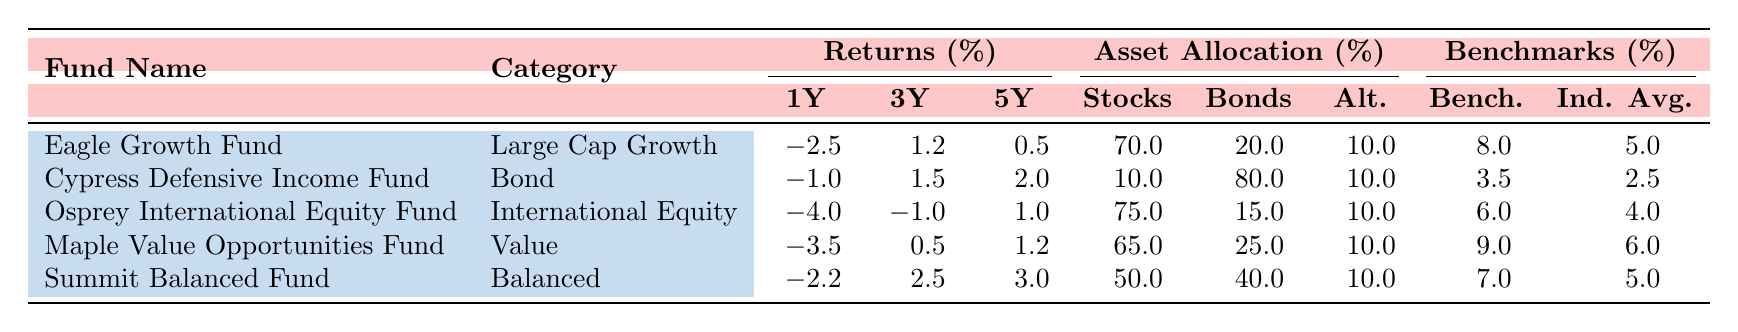What is the one-year return of the Eagle Growth Fund? The one-year return is listed in the table under the "Returns (%)” section for the Eagle Growth Fund, which is -2.5%.
Answer: -2.5% Which fund has the highest five-year return? The highest five-year return can be determined by comparing the values in the "5Y" column. The Summit Balanced Fund has the highest value at 3.0%.
Answer: Summit Balanced Fund What is the asset allocation for bonds in the Cypress Defensive Income Fund? The asset allocation for bonds in the Cypress Defensive Income Fund is specified in the "Asset Allocation (%)" section, which shows 80.0% for bonds.
Answer: 80.0% How does the one-year return of the Osprey International Equity Fund compare to its benchmark return? The one-year return of the Osprey International Equity Fund is -4.0%, while its benchmark return is 6.0%. The difference indicates that the fund is underperforming its benchmark by 10.0%.
Answer: Underperforming by 10.0% What is the total asset allocation percentage for stocks and bonds in the Maple Value Opportunities Fund? To find the total allocation, sum the stocks (65.0%) and bonds (25.0%) allocations listed for the Maple Value Opportunities Fund: 65.0% + 25.0% = 90.0%.
Answer: 90.0% Is the three-year return of the Summit Balanced Fund above the industry average return? The three-year return for the Summit Balanced Fund is 2.5%, while the industry average return is 5.0%. Since 2.5% is below 5.0%, the answer is no.
Answer: No Calculate the average one-year return of all the underperforming funds listed in the table. First, we identify the underperforming funds: Eagle Growth Fund (-2.5%), Cypress Defensive Income Fund (-1.0%), Osprey International Equity Fund (-4.0%), Maple Value Opportunities Fund (-3.5%), and Summit Balanced Fund (-2.2%). Then, the sum of the returns is -2.5 + (-1.0) + (-4.0) + (-3.5) + (-2.2) = -13.2%. Finally, divide by the number of funds (5): -13.2% / 5 = -2.64%.
Answer: -2.64% What percentage of the asset allocation for stocks does the Eagle Growth Fund have compared to the industry average? The Eagle Growth Fund has 70.0% allocated to stocks, while the data does not provide a specific industry average for stocks. Thus, a direct comparison cannot be made. However, it can be said that the fund's allocation is significant.
Answer: Significant allocation Which fund has the highest asset allocation to alternatives? The highest asset allocation to alternatives for all funds listed is 10.0% for each fund, as all of them have the same allocation.
Answer: Tie among all funds Does the Maple Value Opportunities Fund meet or exceed its benchmark return? The Maple Value Opportunities Fund has a benchmark return of 9.0% and a reported return of -3.5%. Since -3.5% is below 9.0%, it does not meet its benchmark.
Answer: No 